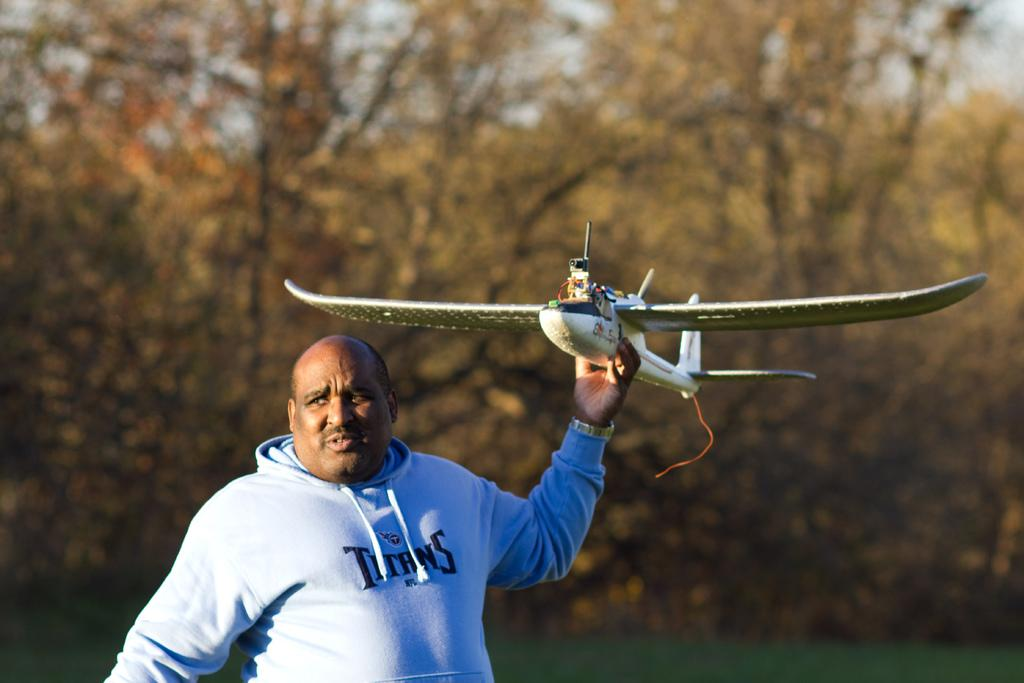<image>
Create a compact narrative representing the image presented. A man wearing a Titans sweatshirt is lifting a remote controlled airplane. 